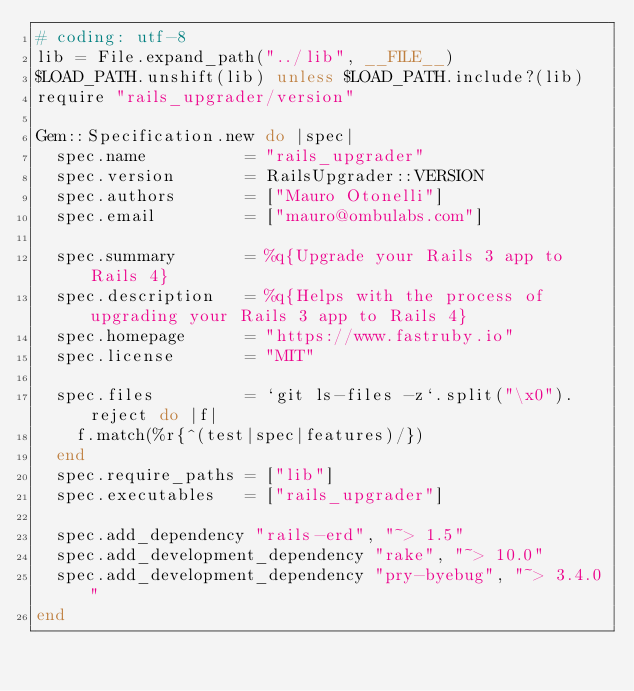Convert code to text. <code><loc_0><loc_0><loc_500><loc_500><_Ruby_># coding: utf-8
lib = File.expand_path("../lib", __FILE__)
$LOAD_PATH.unshift(lib) unless $LOAD_PATH.include?(lib)
require "rails_upgrader/version"

Gem::Specification.new do |spec|
  spec.name          = "rails_upgrader"
  spec.version       = RailsUpgrader::VERSION
  spec.authors       = ["Mauro Otonelli"]
  spec.email         = ["mauro@ombulabs.com"]

  spec.summary       = %q{Upgrade your Rails 3 app to Rails 4}
  spec.description   = %q{Helps with the process of upgrading your Rails 3 app to Rails 4}
  spec.homepage      = "https://www.fastruby.io"
  spec.license       = "MIT"

  spec.files         = `git ls-files -z`.split("\x0").reject do |f|
    f.match(%r{^(test|spec|features)/})
  end
  spec.require_paths = ["lib"]
  spec.executables   = ["rails_upgrader"]

  spec.add_dependency "rails-erd", "~> 1.5"
  spec.add_development_dependency "rake", "~> 10.0"
  spec.add_development_dependency "pry-byebug", "~> 3.4.0"
end
</code> 